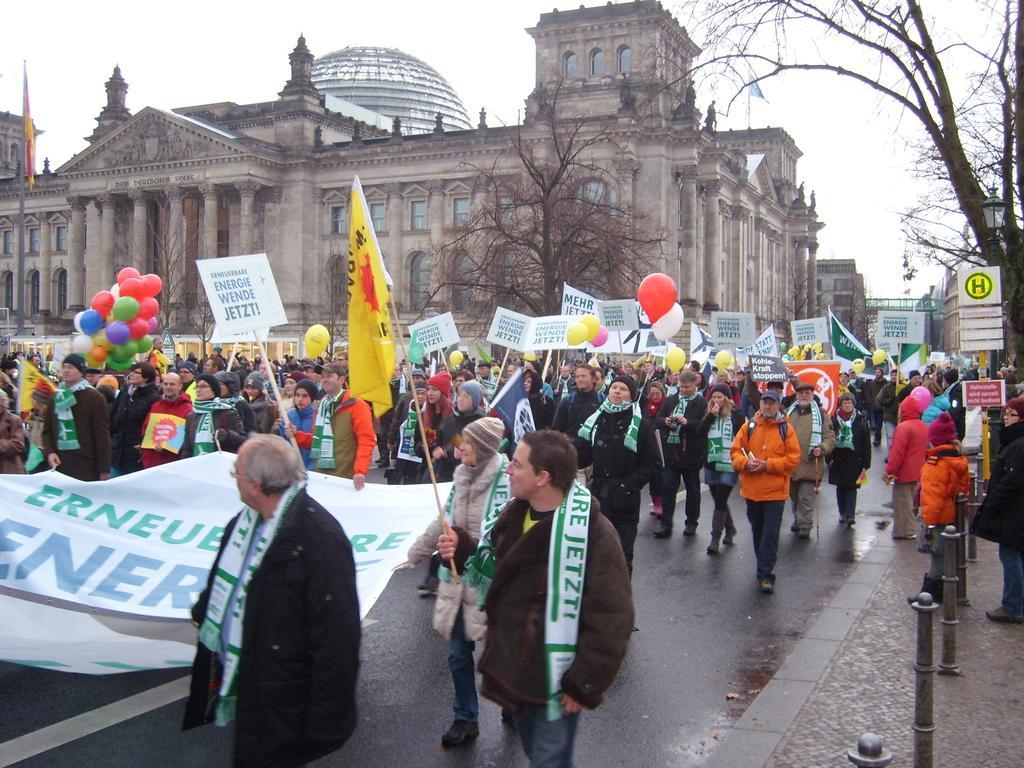How would you summarize this image in a sentence or two? In this image I can see people on the road among them some are holding balloons, placards, flag and a banner. In the background I can see buildings, trees and the sky. Here I can see poles, boards and other objects. 